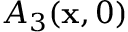Convert formula to latex. <formula><loc_0><loc_0><loc_500><loc_500>A _ { 3 } ( x , 0 )</formula> 